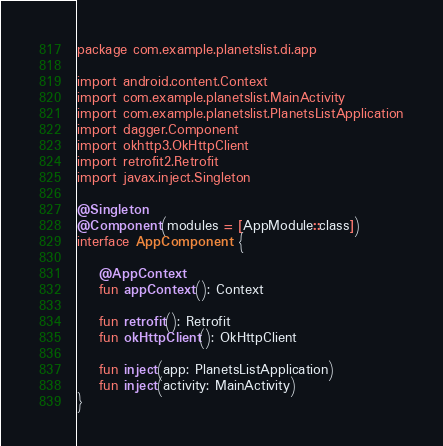Convert code to text. <code><loc_0><loc_0><loc_500><loc_500><_Kotlin_>package com.example.planetslist.di.app

import android.content.Context
import com.example.planetslist.MainActivity
import com.example.planetslist.PlanetsListApplication
import dagger.Component
import okhttp3.OkHttpClient
import retrofit2.Retrofit
import javax.inject.Singleton

@Singleton
@Component(modules = [AppModule::class])
interface AppComponent {

    @AppContext
    fun appContext(): Context

    fun retrofit(): Retrofit
    fun okHttpClient(): OkHttpClient

    fun inject(app: PlanetsListApplication)
    fun inject(activity: MainActivity)
}</code> 